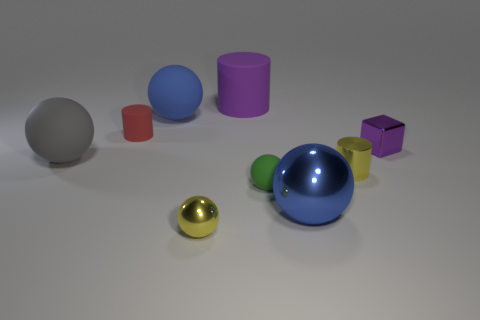Is the number of blue shiny balls to the left of the green matte thing less than the number of blue rubber balls that are to the right of the tiny metallic cylinder?
Keep it short and to the point. No. Does the gray matte sphere have the same size as the sphere that is behind the red rubber thing?
Offer a very short reply. Yes. How many metallic blocks have the same size as the blue rubber object?
Provide a short and direct response. 0. What number of large objects are purple metallic cubes or cyan objects?
Ensure brevity in your answer.  0. Is there a big gray ball?
Ensure brevity in your answer.  Yes. Is the number of purple matte things in front of the small purple thing greater than the number of big purple rubber objects on the left side of the blue matte ball?
Keep it short and to the point. No. What is the color of the matte cylinder that is in front of the big purple cylinder that is behind the tiny purple metal object?
Offer a very short reply. Red. Is there a tiny matte thing that has the same color as the big shiny thing?
Your response must be concise. No. There is a rubber thing that is in front of the tiny cylinder that is in front of the small metal thing that is behind the large gray matte sphere; what is its size?
Offer a terse response. Small. The small green object is what shape?
Give a very brief answer. Sphere. 